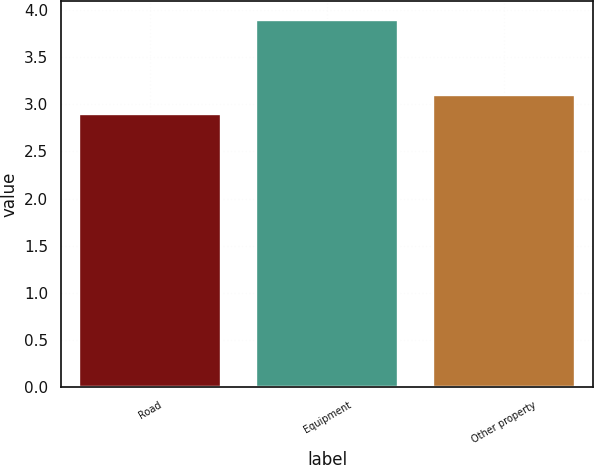<chart> <loc_0><loc_0><loc_500><loc_500><bar_chart><fcel>Road<fcel>Equipment<fcel>Other property<nl><fcel>2.9<fcel>3.9<fcel>3.1<nl></chart> 